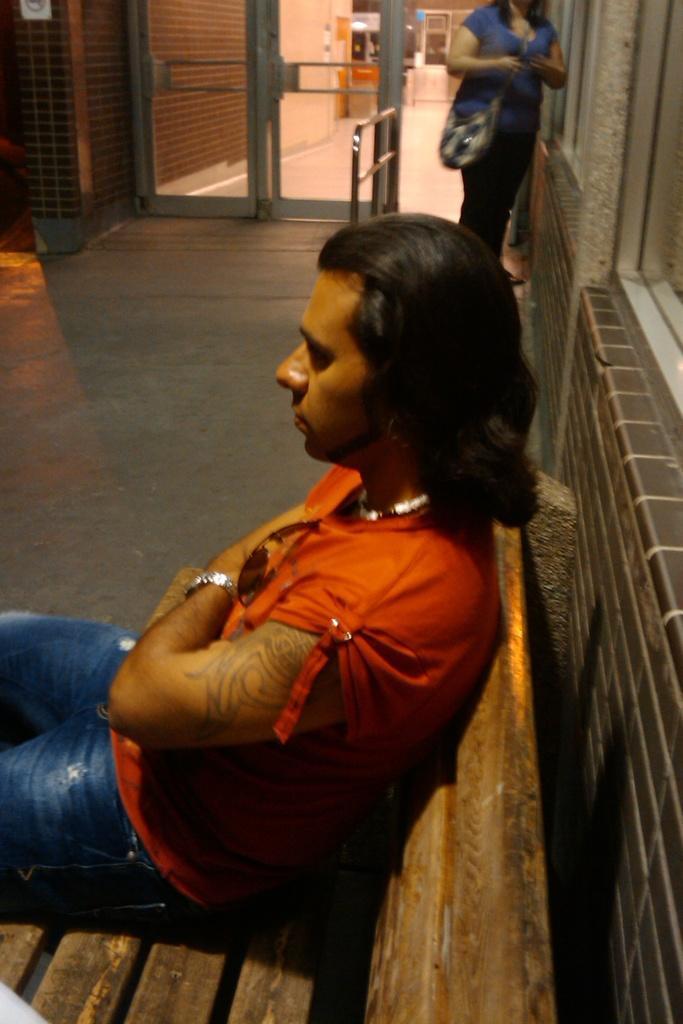In one or two sentences, can you explain what this image depicts? In this picture there is a person sitting on a bench, behind him we can see wall. In the background of the image there is a woman standing on the floor and we can see glass door, through glass door we can see wall and objects. 